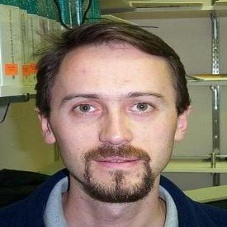The input is a photograph of an object. Identify the main object in the image. The primary focus of the image is the man's face. It is a close-up portrait emphasizing his distinct facial features, particularly his eyes, mustache, and beard. The man's direct gaze and neutral expression suggest that this photograph was intentionally posed, capturing a moment of stillness that allows the viewer to connect with the subject. The image also offers a glimpse into the man's personality and possible mood at the time, encapsulated through the intimate details of his facial expression. 